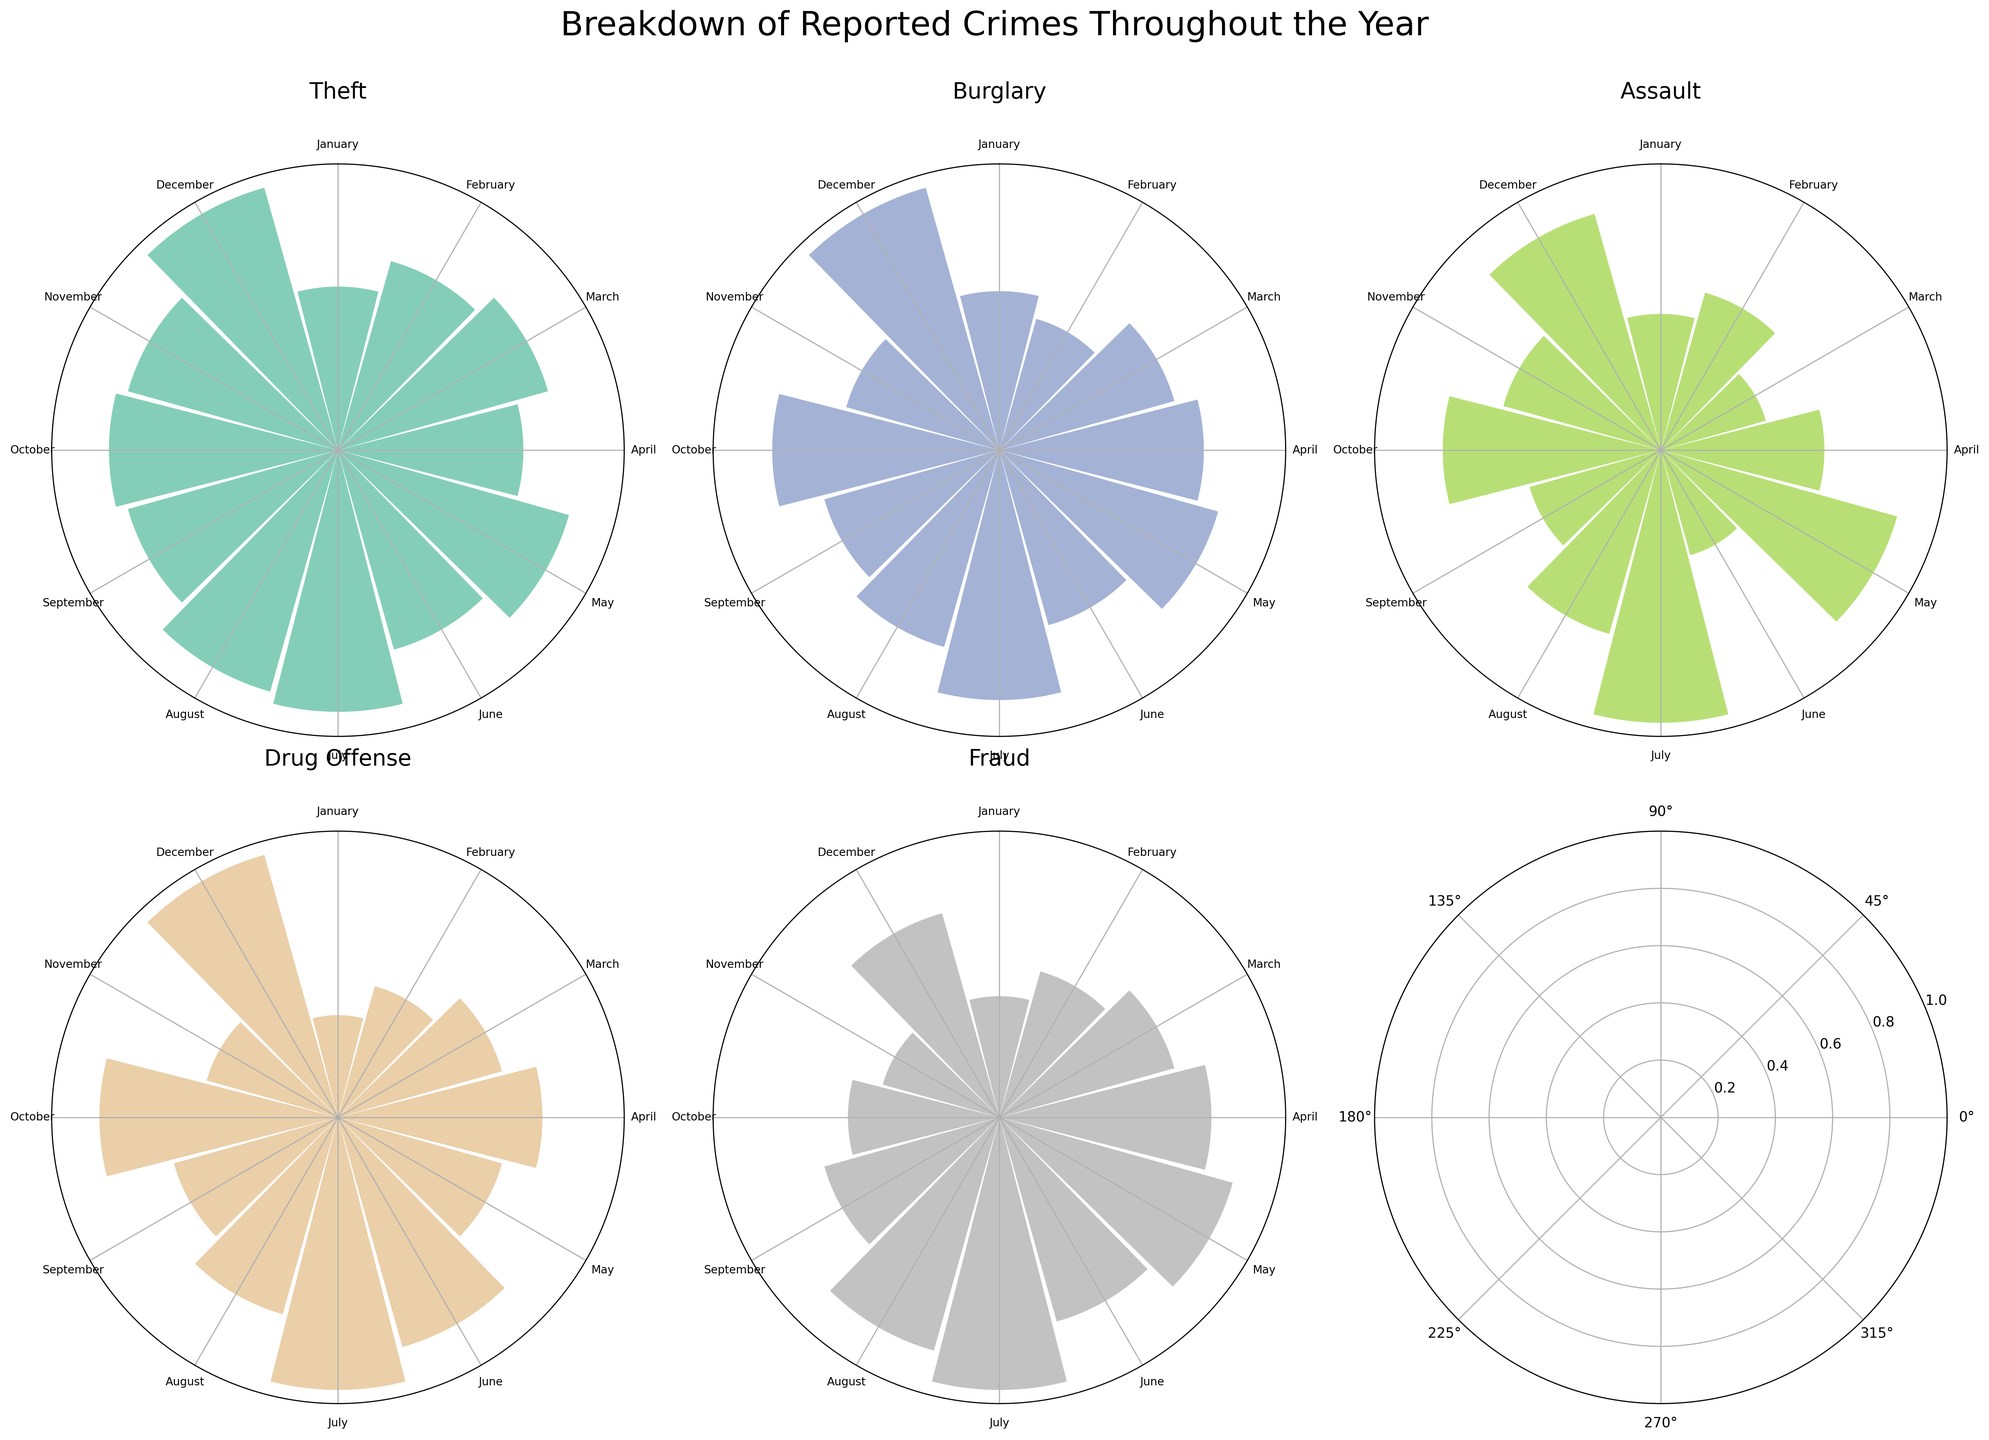What's the title of the figure? The title is usually located at the top of the figure and gives a summary of the contents. In this case, the main title is "Breakdown of Reported Crimes Throughout the Year" as per the code provided.
Answer: Breakdown of Reported Crimes Throughout the Year What color is used to depict "Theft"? Each crime type is assigned a unique color from the Set2 colormap. By inspecting the rose chart subplot titled "Theft", we can identify the specific color used for this category.
Answer: Green (a specific shade from the Set2 colormap) Which month experienced the highest number of "Theft" crimes? By examining the rose chart subplot for "Theft", we can see which bar is the longest, representing the highest number of occurrences. The longest bar for "Theft" corresponds to December.
Answer: December Compare the number of "Assault" crimes in May and October. Which month had more attacks? Look at the rose chart subplot for "Assault", find the bars for May and October, and compare their lengths. The height of each bar indicates the number of occurrences. May has more occurrences than October.
Answer: May What is the total number of "Fraud" crimes reported from January to December? To calculate the total, add the number of "Fraud" crimes from each month by examining the corresponding rose chart subplot. Sum up 4, 5, 6, 7, 8, 7, 9, 8, 6, 5, 4, and 7. The total is 76.
Answer: 76 In which month did "Burglary" crimes peak? Check the rose chart subplot for "Burglary" and identify which month has the tallest bar. The peak is seen in December.
Answer: December Which type of crime showed the most consistent monthly occurrences (least variation)? To determine this, visually compare the lengths of the bars for each type of crime in their respective rose charts. "Drug Offense" shows relatively even bar lengths across all months.
Answer: Drug Offense How do "Assault" crimes in July compare to those in January? Inspect the subplot for "Assault" and compare the bar lengths for July and January. July has a longer bar, indicating more "Assault" crimes.
Answer: July What is the range of occurrences for "Drug Offense" throughout the year? Find the minimum and maximum bar lengths in the "Drug Offense" rose chart subplot. The smallest occurrence is 3 and the largest is 8. The range is 8 - 3 = 5.
Answer: 5 Were there more "Theft" crimes in the first half of the year (Jan-Jun) or the second half (Jul-Dec)? Sum the "Theft" crimes from January to June and compare the total to the sum for July to December. First half: 15+18+20+17+22+19 = 111. Second half: 24+23+20+21+20+25 = 133. The second half has more crimes.
Answer: Second half 